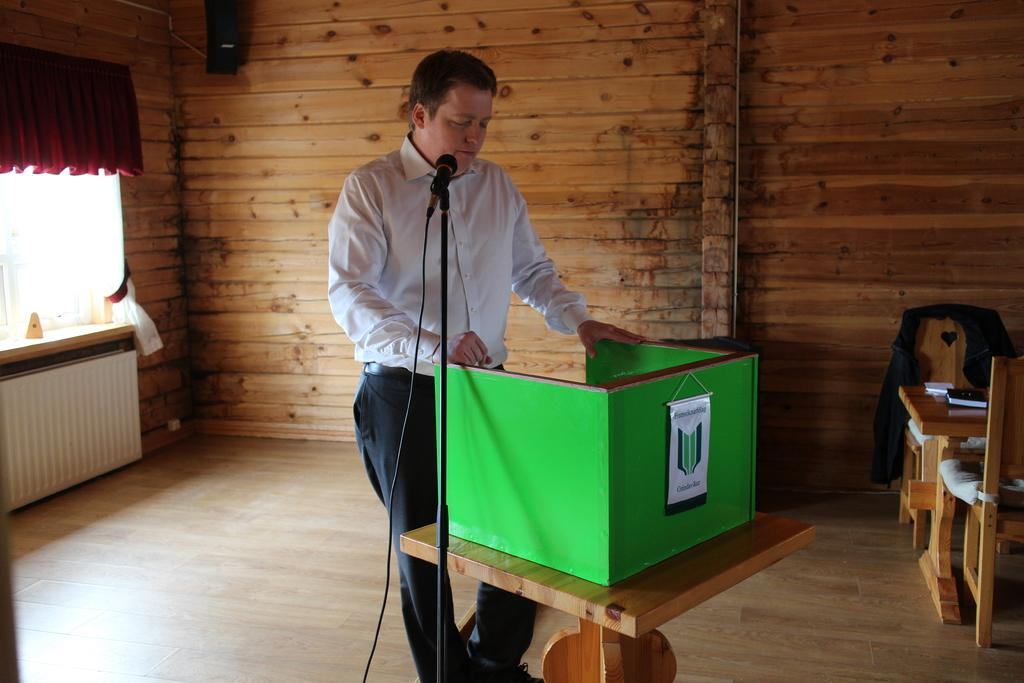Who is the main subject in the image? There is a man in the image. What is the man doing in the image? The man is standing in front of a podium and speaking with the help of a microphone. What objects are present in the image that might be used for seating? There are chairs in the image. What other furniture is present in the image? There is a table in the image. What type of attack is being carried out by the man in the image? There is no attack being carried out in the image; the man is simply speaking at a podium. Can you see a pail in the image? No, there is no pail present in the image. 